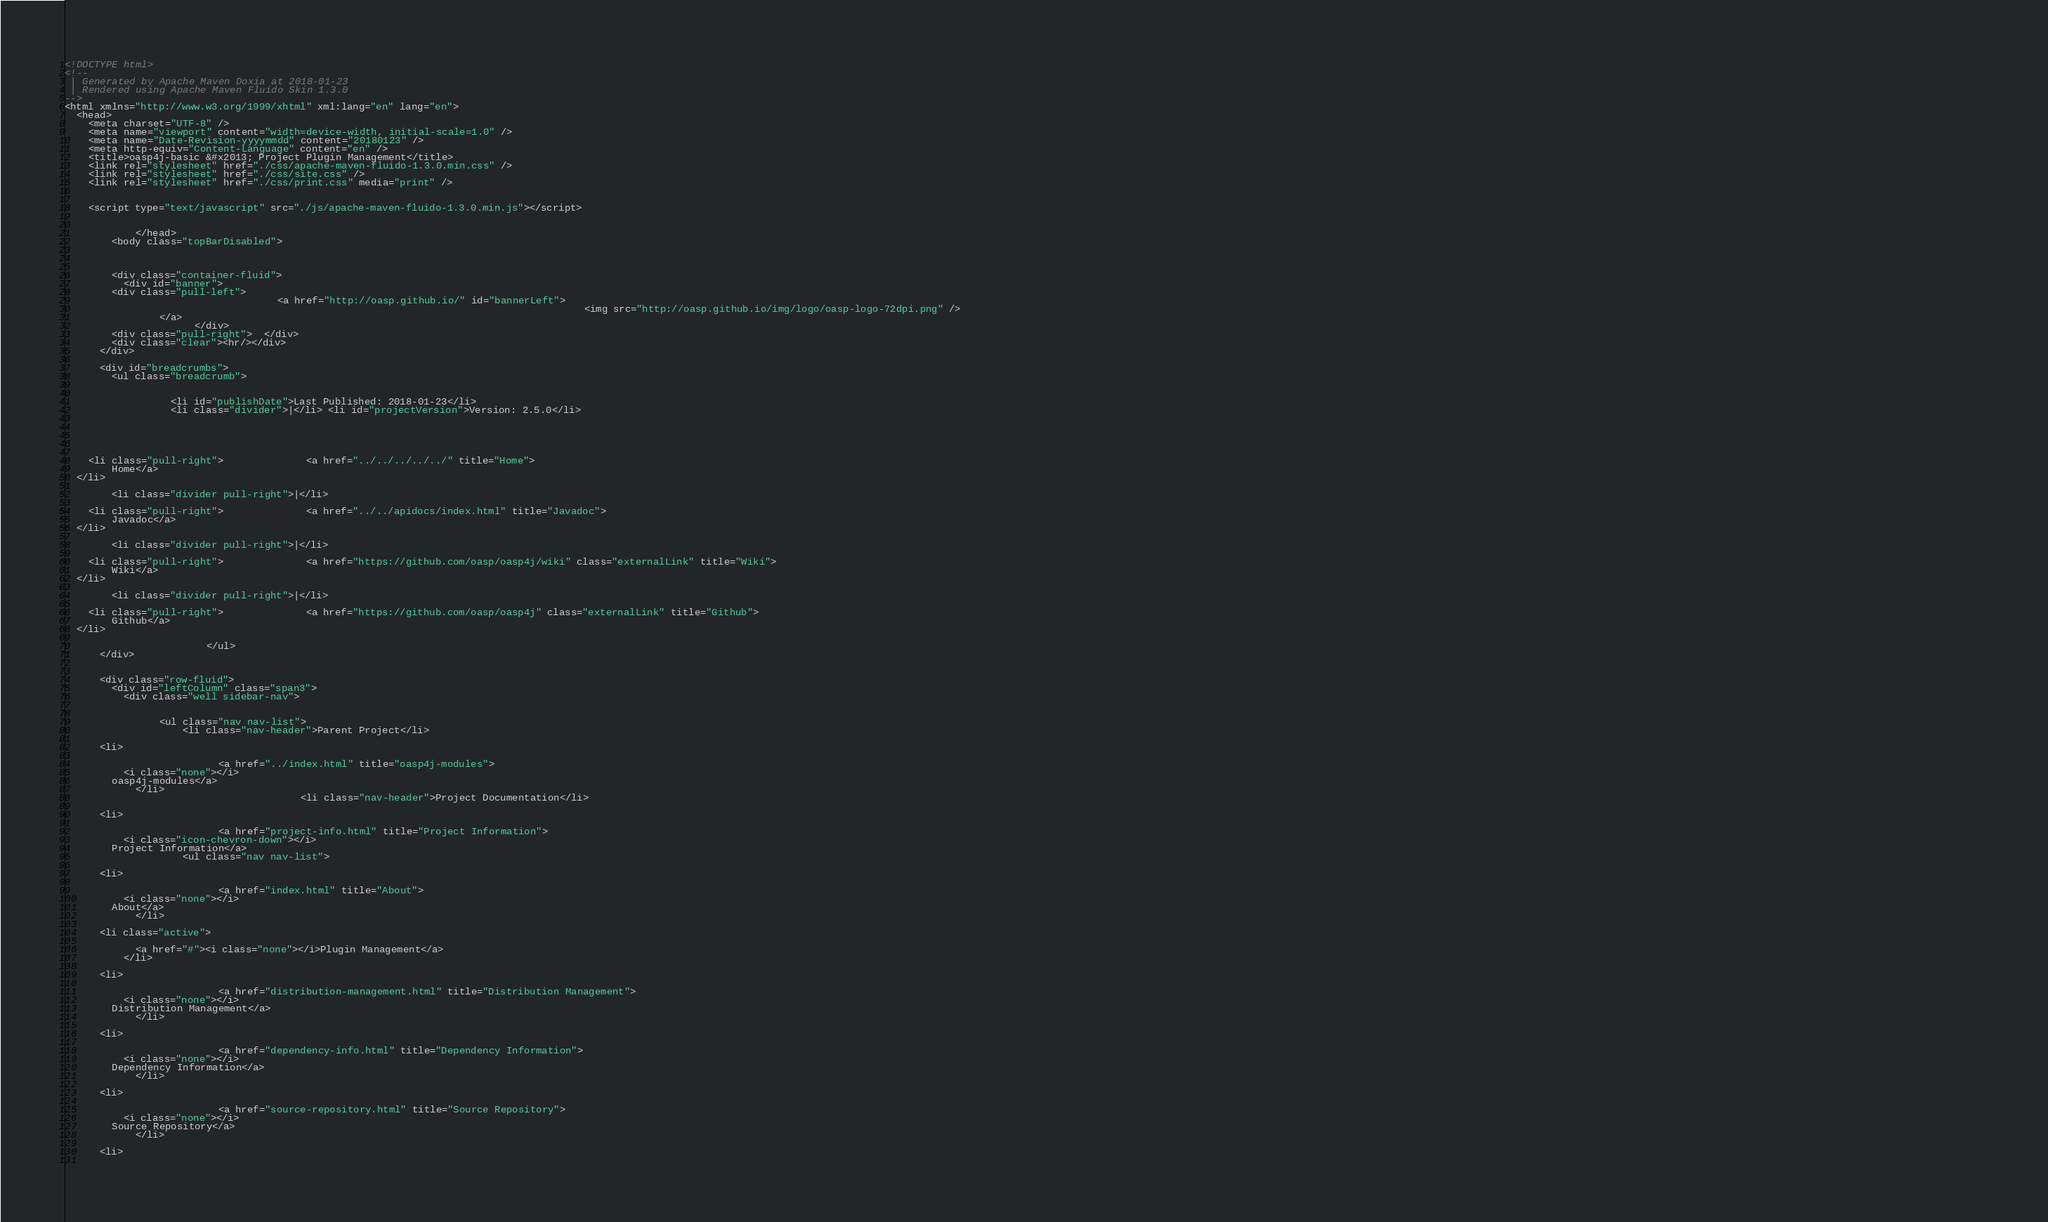<code> <loc_0><loc_0><loc_500><loc_500><_HTML_><!DOCTYPE html>
<!--
 | Generated by Apache Maven Doxia at 2018-01-23
 | Rendered using Apache Maven Fluido Skin 1.3.0
-->
<html xmlns="http://www.w3.org/1999/xhtml" xml:lang="en" lang="en">
  <head>
    <meta charset="UTF-8" />
    <meta name="viewport" content="width=device-width, initial-scale=1.0" />
    <meta name="Date-Revision-yyyymmdd" content="20180123" />
    <meta http-equiv="Content-Language" content="en" />
    <title>oasp4j-basic &#x2013; Project Plugin Management</title>
    <link rel="stylesheet" href="./css/apache-maven-fluido-1.3.0.min.css" />
    <link rel="stylesheet" href="./css/site.css" />
    <link rel="stylesheet" href="./css/print.css" media="print" />

      
    <script type="text/javascript" src="./js/apache-maven-fluido-1.3.0.min.js"></script>

    
            </head>
        <body class="topBarDisabled">
          
        
    
        <div class="container-fluid">
          <div id="banner">
        <div class="pull-left">
                                    <a href="http://oasp.github.io/" id="bannerLeft">
                                                                                        <img src="http://oasp.github.io/img/logo/oasp-logo-72dpi.png" />
                </a>
                      </div>
        <div class="pull-right">  </div>
        <div class="clear"><hr/></div>
      </div>

      <div id="breadcrumbs">
        <ul class="breadcrumb">
                
                    
                  <li id="publishDate">Last Published: 2018-01-23</li>
                  <li class="divider">|</li> <li id="projectVersion">Version: 2.5.0</li>
                      
                
                    
      
                                              
    <li class="pull-right">              <a href="../../../../../" title="Home">
        Home</a>
  </li>

        <li class="divider pull-right">|</li>
      
    <li class="pull-right">              <a href="../../apidocs/index.html" title="Javadoc">
        Javadoc</a>
  </li>

        <li class="divider pull-right">|</li>
      
    <li class="pull-right">              <a href="https://github.com/oasp/oasp4j/wiki" class="externalLink" title="Wiki">
        Wiki</a>
  </li>

        <li class="divider pull-right">|</li>
      
    <li class="pull-right">              <a href="https://github.com/oasp/oasp4j" class="externalLink" title="Github">
        Github</a>
  </li>

                        </ul>
      </div>

            
      <div class="row-fluid">
        <div id="leftColumn" class="span3">
          <div class="well sidebar-nav">
                
                    
                <ul class="nav nav-list">
                    <li class="nav-header">Parent Project</li>
                                
      <li>
    
                          <a href="../index.html" title="oasp4j-modules">
          <i class="none"></i>
        oasp4j-modules</a>
            </li>
                                        <li class="nav-header">Project Documentation</li>
                                                                                                                                                                                                                                                                                                                                      
      <li>
    
                          <a href="project-info.html" title="Project Information">
          <i class="icon-chevron-down"></i>
        Project Information</a>
                    <ul class="nav nav-list">
                      
      <li>
    
                          <a href="index.html" title="About">
          <i class="none"></i>
        About</a>
            </li>
                      
      <li class="active">
    
            <a href="#"><i class="none"></i>Plugin Management</a>
          </li>
                      
      <li>
    
                          <a href="distribution-management.html" title="Distribution Management">
          <i class="none"></i>
        Distribution Management</a>
            </li>
                      
      <li>
    
                          <a href="dependency-info.html" title="Dependency Information">
          <i class="none"></i>
        Dependency Information</a>
            </li>
                      
      <li>
    
                          <a href="source-repository.html" title="Source Repository">
          <i class="none"></i>
        Source Repository</a>
            </li>
                      
      <li>
    </code> 